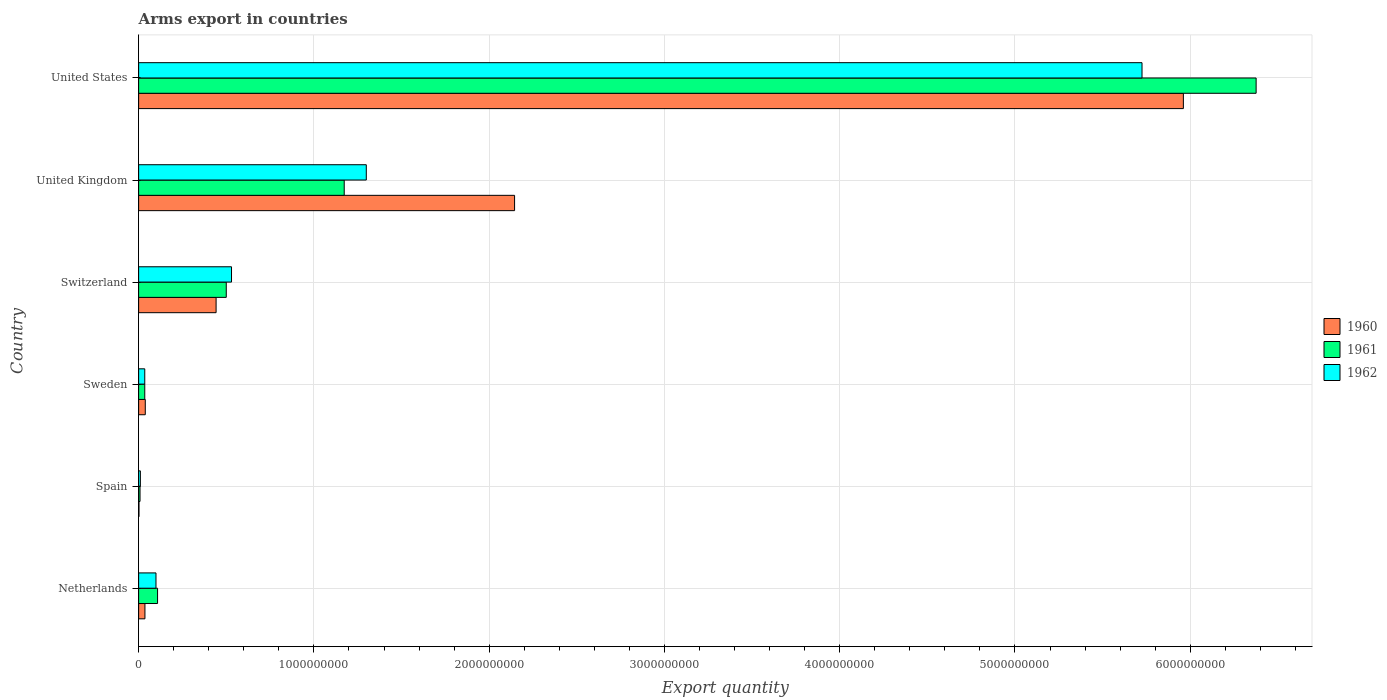How many groups of bars are there?
Your answer should be compact. 6. Are the number of bars per tick equal to the number of legend labels?
Your answer should be compact. Yes. How many bars are there on the 6th tick from the top?
Provide a succinct answer. 3. What is the label of the 1st group of bars from the top?
Provide a short and direct response. United States. In how many cases, is the number of bars for a given country not equal to the number of legend labels?
Make the answer very short. 0. What is the total arms export in 1962 in Spain?
Ensure brevity in your answer.  1.00e+07. Across all countries, what is the maximum total arms export in 1962?
Provide a short and direct response. 5.72e+09. Across all countries, what is the minimum total arms export in 1961?
Make the answer very short. 8.00e+06. What is the total total arms export in 1961 in the graph?
Provide a succinct answer. 8.20e+09. What is the difference between the total arms export in 1960 in Netherlands and that in United States?
Ensure brevity in your answer.  -5.92e+09. What is the difference between the total arms export in 1961 in Switzerland and the total arms export in 1960 in Sweden?
Make the answer very short. 4.62e+08. What is the average total arms export in 1961 per country?
Offer a very short reply. 1.37e+09. What is the difference between the total arms export in 1962 and total arms export in 1961 in Switzerland?
Keep it short and to the point. 3.00e+07. In how many countries, is the total arms export in 1962 greater than 6000000000 ?
Your answer should be very brief. 0. What is the ratio of the total arms export in 1962 in Switzerland to that in United Kingdom?
Keep it short and to the point. 0.41. Is the total arms export in 1960 in Netherlands less than that in United States?
Keep it short and to the point. Yes. Is the difference between the total arms export in 1962 in Netherlands and United Kingdom greater than the difference between the total arms export in 1961 in Netherlands and United Kingdom?
Offer a terse response. No. What is the difference between the highest and the second highest total arms export in 1962?
Provide a short and direct response. 4.43e+09. What is the difference between the highest and the lowest total arms export in 1961?
Provide a succinct answer. 6.37e+09. What does the 1st bar from the top in United States represents?
Offer a terse response. 1962. What does the 1st bar from the bottom in United Kingdom represents?
Provide a short and direct response. 1960. Is it the case that in every country, the sum of the total arms export in 1962 and total arms export in 1960 is greater than the total arms export in 1961?
Your response must be concise. Yes. How many countries are there in the graph?
Keep it short and to the point. 6. Does the graph contain grids?
Provide a short and direct response. Yes. Where does the legend appear in the graph?
Provide a short and direct response. Center right. How many legend labels are there?
Make the answer very short. 3. How are the legend labels stacked?
Offer a very short reply. Vertical. What is the title of the graph?
Your response must be concise. Arms export in countries. Does "1968" appear as one of the legend labels in the graph?
Make the answer very short. No. What is the label or title of the X-axis?
Your answer should be very brief. Export quantity. What is the label or title of the Y-axis?
Provide a succinct answer. Country. What is the Export quantity of 1960 in Netherlands?
Ensure brevity in your answer.  3.60e+07. What is the Export quantity of 1961 in Netherlands?
Your response must be concise. 1.08e+08. What is the Export quantity in 1962 in Netherlands?
Give a very brief answer. 9.90e+07. What is the Export quantity in 1960 in Spain?
Your response must be concise. 2.00e+06. What is the Export quantity in 1960 in Sweden?
Your answer should be very brief. 3.80e+07. What is the Export quantity of 1961 in Sweden?
Give a very brief answer. 3.50e+07. What is the Export quantity in 1962 in Sweden?
Offer a very short reply. 3.50e+07. What is the Export quantity of 1960 in Switzerland?
Your answer should be compact. 4.42e+08. What is the Export quantity of 1961 in Switzerland?
Provide a succinct answer. 5.00e+08. What is the Export quantity in 1962 in Switzerland?
Provide a succinct answer. 5.30e+08. What is the Export quantity of 1960 in United Kingdom?
Keep it short and to the point. 2.14e+09. What is the Export quantity of 1961 in United Kingdom?
Provide a succinct answer. 1.17e+09. What is the Export quantity of 1962 in United Kingdom?
Your answer should be very brief. 1.30e+09. What is the Export quantity in 1960 in United States?
Offer a very short reply. 5.96e+09. What is the Export quantity of 1961 in United States?
Give a very brief answer. 6.38e+09. What is the Export quantity of 1962 in United States?
Offer a terse response. 5.72e+09. Across all countries, what is the maximum Export quantity in 1960?
Your answer should be compact. 5.96e+09. Across all countries, what is the maximum Export quantity in 1961?
Provide a short and direct response. 6.38e+09. Across all countries, what is the maximum Export quantity in 1962?
Keep it short and to the point. 5.72e+09. Across all countries, what is the minimum Export quantity of 1961?
Your answer should be very brief. 8.00e+06. Across all countries, what is the minimum Export quantity of 1962?
Your answer should be compact. 1.00e+07. What is the total Export quantity of 1960 in the graph?
Your answer should be compact. 8.62e+09. What is the total Export quantity of 1961 in the graph?
Ensure brevity in your answer.  8.20e+09. What is the total Export quantity in 1962 in the graph?
Give a very brief answer. 7.70e+09. What is the difference between the Export quantity of 1960 in Netherlands and that in Spain?
Your response must be concise. 3.40e+07. What is the difference between the Export quantity in 1962 in Netherlands and that in Spain?
Provide a succinct answer. 8.90e+07. What is the difference between the Export quantity of 1961 in Netherlands and that in Sweden?
Provide a short and direct response. 7.30e+07. What is the difference between the Export quantity of 1962 in Netherlands and that in Sweden?
Your answer should be compact. 6.40e+07. What is the difference between the Export quantity in 1960 in Netherlands and that in Switzerland?
Your answer should be very brief. -4.06e+08. What is the difference between the Export quantity of 1961 in Netherlands and that in Switzerland?
Keep it short and to the point. -3.92e+08. What is the difference between the Export quantity of 1962 in Netherlands and that in Switzerland?
Offer a very short reply. -4.31e+08. What is the difference between the Export quantity in 1960 in Netherlands and that in United Kingdom?
Offer a terse response. -2.11e+09. What is the difference between the Export quantity in 1961 in Netherlands and that in United Kingdom?
Offer a very short reply. -1.06e+09. What is the difference between the Export quantity of 1962 in Netherlands and that in United Kingdom?
Your answer should be compact. -1.20e+09. What is the difference between the Export quantity of 1960 in Netherlands and that in United States?
Ensure brevity in your answer.  -5.92e+09. What is the difference between the Export quantity in 1961 in Netherlands and that in United States?
Give a very brief answer. -6.27e+09. What is the difference between the Export quantity in 1962 in Netherlands and that in United States?
Provide a succinct answer. -5.63e+09. What is the difference between the Export quantity of 1960 in Spain and that in Sweden?
Provide a succinct answer. -3.60e+07. What is the difference between the Export quantity of 1961 in Spain and that in Sweden?
Your answer should be very brief. -2.70e+07. What is the difference between the Export quantity of 1962 in Spain and that in Sweden?
Make the answer very short. -2.50e+07. What is the difference between the Export quantity in 1960 in Spain and that in Switzerland?
Offer a very short reply. -4.40e+08. What is the difference between the Export quantity of 1961 in Spain and that in Switzerland?
Your answer should be very brief. -4.92e+08. What is the difference between the Export quantity in 1962 in Spain and that in Switzerland?
Ensure brevity in your answer.  -5.20e+08. What is the difference between the Export quantity of 1960 in Spain and that in United Kingdom?
Provide a short and direct response. -2.14e+09. What is the difference between the Export quantity of 1961 in Spain and that in United Kingdom?
Offer a very short reply. -1.16e+09. What is the difference between the Export quantity in 1962 in Spain and that in United Kingdom?
Provide a succinct answer. -1.29e+09. What is the difference between the Export quantity of 1960 in Spain and that in United States?
Your answer should be very brief. -5.96e+09. What is the difference between the Export quantity in 1961 in Spain and that in United States?
Offer a terse response. -6.37e+09. What is the difference between the Export quantity in 1962 in Spain and that in United States?
Make the answer very short. -5.72e+09. What is the difference between the Export quantity of 1960 in Sweden and that in Switzerland?
Offer a very short reply. -4.04e+08. What is the difference between the Export quantity in 1961 in Sweden and that in Switzerland?
Provide a short and direct response. -4.65e+08. What is the difference between the Export quantity in 1962 in Sweden and that in Switzerland?
Your answer should be very brief. -4.95e+08. What is the difference between the Export quantity in 1960 in Sweden and that in United Kingdom?
Keep it short and to the point. -2.11e+09. What is the difference between the Export quantity in 1961 in Sweden and that in United Kingdom?
Provide a short and direct response. -1.14e+09. What is the difference between the Export quantity in 1962 in Sweden and that in United Kingdom?
Keep it short and to the point. -1.26e+09. What is the difference between the Export quantity in 1960 in Sweden and that in United States?
Provide a succinct answer. -5.92e+09. What is the difference between the Export quantity of 1961 in Sweden and that in United States?
Provide a succinct answer. -6.34e+09. What is the difference between the Export quantity of 1962 in Sweden and that in United States?
Keep it short and to the point. -5.69e+09. What is the difference between the Export quantity in 1960 in Switzerland and that in United Kingdom?
Make the answer very short. -1.70e+09. What is the difference between the Export quantity in 1961 in Switzerland and that in United Kingdom?
Provide a succinct answer. -6.73e+08. What is the difference between the Export quantity in 1962 in Switzerland and that in United Kingdom?
Provide a short and direct response. -7.69e+08. What is the difference between the Export quantity of 1960 in Switzerland and that in United States?
Your answer should be very brief. -5.52e+09. What is the difference between the Export quantity in 1961 in Switzerland and that in United States?
Your answer should be very brief. -5.88e+09. What is the difference between the Export quantity in 1962 in Switzerland and that in United States?
Offer a very short reply. -5.20e+09. What is the difference between the Export quantity in 1960 in United Kingdom and that in United States?
Make the answer very short. -3.82e+09. What is the difference between the Export quantity in 1961 in United Kingdom and that in United States?
Your answer should be very brief. -5.20e+09. What is the difference between the Export quantity in 1962 in United Kingdom and that in United States?
Your response must be concise. -4.43e+09. What is the difference between the Export quantity of 1960 in Netherlands and the Export quantity of 1961 in Spain?
Your answer should be very brief. 2.80e+07. What is the difference between the Export quantity of 1960 in Netherlands and the Export quantity of 1962 in Spain?
Your response must be concise. 2.60e+07. What is the difference between the Export quantity in 1961 in Netherlands and the Export quantity in 1962 in Spain?
Your response must be concise. 9.80e+07. What is the difference between the Export quantity of 1961 in Netherlands and the Export quantity of 1962 in Sweden?
Keep it short and to the point. 7.30e+07. What is the difference between the Export quantity in 1960 in Netherlands and the Export quantity in 1961 in Switzerland?
Offer a very short reply. -4.64e+08. What is the difference between the Export quantity of 1960 in Netherlands and the Export quantity of 1962 in Switzerland?
Your answer should be very brief. -4.94e+08. What is the difference between the Export quantity of 1961 in Netherlands and the Export quantity of 1962 in Switzerland?
Your answer should be compact. -4.22e+08. What is the difference between the Export quantity in 1960 in Netherlands and the Export quantity in 1961 in United Kingdom?
Keep it short and to the point. -1.14e+09. What is the difference between the Export quantity in 1960 in Netherlands and the Export quantity in 1962 in United Kingdom?
Offer a very short reply. -1.26e+09. What is the difference between the Export quantity in 1961 in Netherlands and the Export quantity in 1962 in United Kingdom?
Make the answer very short. -1.19e+09. What is the difference between the Export quantity in 1960 in Netherlands and the Export quantity in 1961 in United States?
Offer a terse response. -6.34e+09. What is the difference between the Export quantity in 1960 in Netherlands and the Export quantity in 1962 in United States?
Give a very brief answer. -5.69e+09. What is the difference between the Export quantity in 1961 in Netherlands and the Export quantity in 1962 in United States?
Give a very brief answer. -5.62e+09. What is the difference between the Export quantity of 1960 in Spain and the Export quantity of 1961 in Sweden?
Give a very brief answer. -3.30e+07. What is the difference between the Export quantity of 1960 in Spain and the Export quantity of 1962 in Sweden?
Your response must be concise. -3.30e+07. What is the difference between the Export quantity of 1961 in Spain and the Export quantity of 1962 in Sweden?
Your answer should be very brief. -2.70e+07. What is the difference between the Export quantity of 1960 in Spain and the Export quantity of 1961 in Switzerland?
Keep it short and to the point. -4.98e+08. What is the difference between the Export quantity in 1960 in Spain and the Export quantity in 1962 in Switzerland?
Your response must be concise. -5.28e+08. What is the difference between the Export quantity of 1961 in Spain and the Export quantity of 1962 in Switzerland?
Give a very brief answer. -5.22e+08. What is the difference between the Export quantity in 1960 in Spain and the Export quantity in 1961 in United Kingdom?
Offer a terse response. -1.17e+09. What is the difference between the Export quantity of 1960 in Spain and the Export quantity of 1962 in United Kingdom?
Your answer should be very brief. -1.30e+09. What is the difference between the Export quantity of 1961 in Spain and the Export quantity of 1962 in United Kingdom?
Ensure brevity in your answer.  -1.29e+09. What is the difference between the Export quantity of 1960 in Spain and the Export quantity of 1961 in United States?
Provide a succinct answer. -6.37e+09. What is the difference between the Export quantity of 1960 in Spain and the Export quantity of 1962 in United States?
Ensure brevity in your answer.  -5.72e+09. What is the difference between the Export quantity in 1961 in Spain and the Export quantity in 1962 in United States?
Your answer should be very brief. -5.72e+09. What is the difference between the Export quantity of 1960 in Sweden and the Export quantity of 1961 in Switzerland?
Offer a terse response. -4.62e+08. What is the difference between the Export quantity in 1960 in Sweden and the Export quantity in 1962 in Switzerland?
Provide a succinct answer. -4.92e+08. What is the difference between the Export quantity of 1961 in Sweden and the Export quantity of 1962 in Switzerland?
Your answer should be compact. -4.95e+08. What is the difference between the Export quantity of 1960 in Sweden and the Export quantity of 1961 in United Kingdom?
Make the answer very short. -1.14e+09. What is the difference between the Export quantity in 1960 in Sweden and the Export quantity in 1962 in United Kingdom?
Provide a short and direct response. -1.26e+09. What is the difference between the Export quantity of 1961 in Sweden and the Export quantity of 1962 in United Kingdom?
Your response must be concise. -1.26e+09. What is the difference between the Export quantity of 1960 in Sweden and the Export quantity of 1961 in United States?
Offer a very short reply. -6.34e+09. What is the difference between the Export quantity in 1960 in Sweden and the Export quantity in 1962 in United States?
Keep it short and to the point. -5.69e+09. What is the difference between the Export quantity of 1961 in Sweden and the Export quantity of 1962 in United States?
Make the answer very short. -5.69e+09. What is the difference between the Export quantity of 1960 in Switzerland and the Export quantity of 1961 in United Kingdom?
Provide a succinct answer. -7.31e+08. What is the difference between the Export quantity of 1960 in Switzerland and the Export quantity of 1962 in United Kingdom?
Your response must be concise. -8.57e+08. What is the difference between the Export quantity of 1961 in Switzerland and the Export quantity of 1962 in United Kingdom?
Offer a terse response. -7.99e+08. What is the difference between the Export quantity in 1960 in Switzerland and the Export quantity in 1961 in United States?
Your answer should be compact. -5.93e+09. What is the difference between the Export quantity in 1960 in Switzerland and the Export quantity in 1962 in United States?
Offer a terse response. -5.28e+09. What is the difference between the Export quantity in 1961 in Switzerland and the Export quantity in 1962 in United States?
Provide a short and direct response. -5.22e+09. What is the difference between the Export quantity of 1960 in United Kingdom and the Export quantity of 1961 in United States?
Provide a short and direct response. -4.23e+09. What is the difference between the Export quantity of 1960 in United Kingdom and the Export quantity of 1962 in United States?
Provide a succinct answer. -3.58e+09. What is the difference between the Export quantity of 1961 in United Kingdom and the Export quantity of 1962 in United States?
Your response must be concise. -4.55e+09. What is the average Export quantity of 1960 per country?
Provide a succinct answer. 1.44e+09. What is the average Export quantity of 1961 per country?
Provide a succinct answer. 1.37e+09. What is the average Export quantity in 1962 per country?
Provide a succinct answer. 1.28e+09. What is the difference between the Export quantity of 1960 and Export quantity of 1961 in Netherlands?
Ensure brevity in your answer.  -7.20e+07. What is the difference between the Export quantity in 1960 and Export quantity in 1962 in Netherlands?
Ensure brevity in your answer.  -6.30e+07. What is the difference between the Export quantity in 1961 and Export quantity in 1962 in Netherlands?
Give a very brief answer. 9.00e+06. What is the difference between the Export quantity of 1960 and Export quantity of 1961 in Spain?
Your response must be concise. -6.00e+06. What is the difference between the Export quantity of 1960 and Export quantity of 1962 in Spain?
Provide a short and direct response. -8.00e+06. What is the difference between the Export quantity in 1960 and Export quantity in 1961 in Sweden?
Give a very brief answer. 3.00e+06. What is the difference between the Export quantity of 1960 and Export quantity of 1962 in Sweden?
Your response must be concise. 3.00e+06. What is the difference between the Export quantity in 1960 and Export quantity in 1961 in Switzerland?
Your answer should be compact. -5.80e+07. What is the difference between the Export quantity of 1960 and Export quantity of 1962 in Switzerland?
Your answer should be very brief. -8.80e+07. What is the difference between the Export quantity of 1961 and Export quantity of 1962 in Switzerland?
Keep it short and to the point. -3.00e+07. What is the difference between the Export quantity of 1960 and Export quantity of 1961 in United Kingdom?
Your answer should be very brief. 9.72e+08. What is the difference between the Export quantity in 1960 and Export quantity in 1962 in United Kingdom?
Make the answer very short. 8.46e+08. What is the difference between the Export quantity of 1961 and Export quantity of 1962 in United Kingdom?
Provide a short and direct response. -1.26e+08. What is the difference between the Export quantity in 1960 and Export quantity in 1961 in United States?
Keep it short and to the point. -4.15e+08. What is the difference between the Export quantity in 1960 and Export quantity in 1962 in United States?
Offer a very short reply. 2.36e+08. What is the difference between the Export quantity in 1961 and Export quantity in 1962 in United States?
Your response must be concise. 6.51e+08. What is the ratio of the Export quantity of 1962 in Netherlands to that in Spain?
Provide a short and direct response. 9.9. What is the ratio of the Export quantity of 1960 in Netherlands to that in Sweden?
Give a very brief answer. 0.95. What is the ratio of the Export quantity of 1961 in Netherlands to that in Sweden?
Your answer should be very brief. 3.09. What is the ratio of the Export quantity in 1962 in Netherlands to that in Sweden?
Your answer should be compact. 2.83. What is the ratio of the Export quantity of 1960 in Netherlands to that in Switzerland?
Provide a short and direct response. 0.08. What is the ratio of the Export quantity of 1961 in Netherlands to that in Switzerland?
Offer a very short reply. 0.22. What is the ratio of the Export quantity of 1962 in Netherlands to that in Switzerland?
Ensure brevity in your answer.  0.19. What is the ratio of the Export quantity in 1960 in Netherlands to that in United Kingdom?
Offer a very short reply. 0.02. What is the ratio of the Export quantity in 1961 in Netherlands to that in United Kingdom?
Give a very brief answer. 0.09. What is the ratio of the Export quantity in 1962 in Netherlands to that in United Kingdom?
Keep it short and to the point. 0.08. What is the ratio of the Export quantity of 1960 in Netherlands to that in United States?
Give a very brief answer. 0.01. What is the ratio of the Export quantity in 1961 in Netherlands to that in United States?
Provide a short and direct response. 0.02. What is the ratio of the Export quantity in 1962 in Netherlands to that in United States?
Offer a terse response. 0.02. What is the ratio of the Export quantity in 1960 in Spain to that in Sweden?
Provide a short and direct response. 0.05. What is the ratio of the Export quantity in 1961 in Spain to that in Sweden?
Provide a succinct answer. 0.23. What is the ratio of the Export quantity of 1962 in Spain to that in Sweden?
Offer a terse response. 0.29. What is the ratio of the Export quantity of 1960 in Spain to that in Switzerland?
Provide a short and direct response. 0. What is the ratio of the Export quantity in 1961 in Spain to that in Switzerland?
Give a very brief answer. 0.02. What is the ratio of the Export quantity in 1962 in Spain to that in Switzerland?
Offer a terse response. 0.02. What is the ratio of the Export quantity of 1960 in Spain to that in United Kingdom?
Make the answer very short. 0. What is the ratio of the Export quantity in 1961 in Spain to that in United Kingdom?
Keep it short and to the point. 0.01. What is the ratio of the Export quantity in 1962 in Spain to that in United Kingdom?
Keep it short and to the point. 0.01. What is the ratio of the Export quantity of 1960 in Spain to that in United States?
Offer a very short reply. 0. What is the ratio of the Export quantity in 1961 in Spain to that in United States?
Provide a succinct answer. 0. What is the ratio of the Export quantity of 1962 in Spain to that in United States?
Your answer should be very brief. 0. What is the ratio of the Export quantity in 1960 in Sweden to that in Switzerland?
Provide a short and direct response. 0.09. What is the ratio of the Export quantity in 1961 in Sweden to that in Switzerland?
Your response must be concise. 0.07. What is the ratio of the Export quantity of 1962 in Sweden to that in Switzerland?
Provide a succinct answer. 0.07. What is the ratio of the Export quantity in 1960 in Sweden to that in United Kingdom?
Give a very brief answer. 0.02. What is the ratio of the Export quantity of 1961 in Sweden to that in United Kingdom?
Provide a succinct answer. 0.03. What is the ratio of the Export quantity of 1962 in Sweden to that in United Kingdom?
Give a very brief answer. 0.03. What is the ratio of the Export quantity of 1960 in Sweden to that in United States?
Make the answer very short. 0.01. What is the ratio of the Export quantity in 1961 in Sweden to that in United States?
Provide a succinct answer. 0.01. What is the ratio of the Export quantity of 1962 in Sweden to that in United States?
Ensure brevity in your answer.  0.01. What is the ratio of the Export quantity in 1960 in Switzerland to that in United Kingdom?
Ensure brevity in your answer.  0.21. What is the ratio of the Export quantity of 1961 in Switzerland to that in United Kingdom?
Keep it short and to the point. 0.43. What is the ratio of the Export quantity in 1962 in Switzerland to that in United Kingdom?
Ensure brevity in your answer.  0.41. What is the ratio of the Export quantity of 1960 in Switzerland to that in United States?
Provide a succinct answer. 0.07. What is the ratio of the Export quantity in 1961 in Switzerland to that in United States?
Ensure brevity in your answer.  0.08. What is the ratio of the Export quantity of 1962 in Switzerland to that in United States?
Keep it short and to the point. 0.09. What is the ratio of the Export quantity of 1960 in United Kingdom to that in United States?
Keep it short and to the point. 0.36. What is the ratio of the Export quantity in 1961 in United Kingdom to that in United States?
Your answer should be very brief. 0.18. What is the ratio of the Export quantity of 1962 in United Kingdom to that in United States?
Ensure brevity in your answer.  0.23. What is the difference between the highest and the second highest Export quantity in 1960?
Your answer should be very brief. 3.82e+09. What is the difference between the highest and the second highest Export quantity in 1961?
Your response must be concise. 5.20e+09. What is the difference between the highest and the second highest Export quantity of 1962?
Offer a terse response. 4.43e+09. What is the difference between the highest and the lowest Export quantity of 1960?
Offer a terse response. 5.96e+09. What is the difference between the highest and the lowest Export quantity in 1961?
Your answer should be compact. 6.37e+09. What is the difference between the highest and the lowest Export quantity in 1962?
Provide a succinct answer. 5.72e+09. 